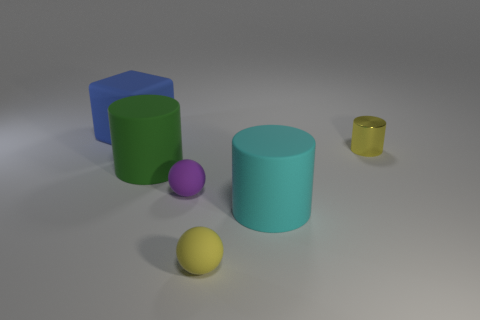What number of other things are there of the same size as the yellow cylinder?
Give a very brief answer. 2. What number of objects are small objects to the left of the yellow shiny cylinder or rubber objects in front of the metallic thing?
Provide a succinct answer. 4. Is the material of the big cyan object the same as the small yellow thing that is behind the cyan matte cylinder?
Your answer should be very brief. No. How many other objects are the same shape as the large blue rubber thing?
Your answer should be very brief. 0. What is the small yellow object that is in front of the small sphere on the left side of the tiny yellow object in front of the yellow metallic object made of?
Offer a very short reply. Rubber. Are there the same number of small purple balls behind the green matte cylinder and large brown shiny cylinders?
Your response must be concise. Yes. Is the yellow thing in front of the small metal thing made of the same material as the small thing that is on the right side of the large cyan cylinder?
Your answer should be very brief. No. Is there any other thing that is made of the same material as the cyan cylinder?
Your response must be concise. Yes. There is a thing that is to the right of the cyan cylinder; is it the same shape as the tiny rubber thing in front of the big cyan rubber cylinder?
Provide a succinct answer. No. Is the number of rubber spheres that are behind the large blue cube less than the number of big red cylinders?
Make the answer very short. No. 